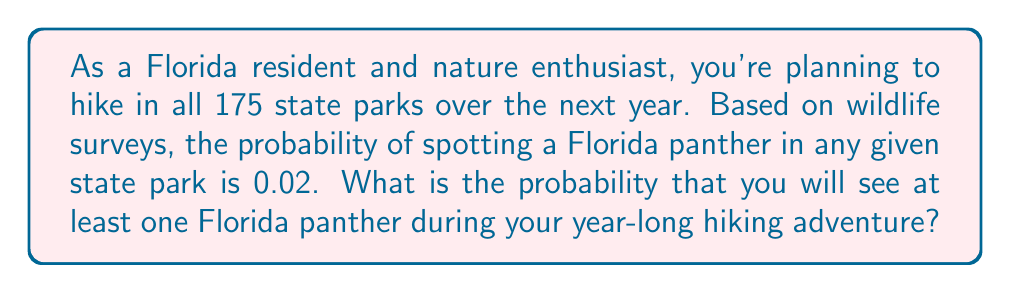Give your solution to this math problem. To solve this problem, we'll use the complement rule of probability. Instead of calculating the probability of seeing at least one panther, we'll calculate the probability of not seeing any panthers and then subtract that from 1.

Let's break it down step by step:

1) The probability of not seeing a panther in one park is:
   $1 - 0.02 = 0.98$

2) You're visiting all 175 state parks. To not see a panther at all, you would need to not see one in every single park. The probability of this happening is:
   $(0.98)^{175}$

3) Therefore, the probability of seeing at least one panther is:
   $1 - (0.98)^{175}$

4) Let's calculate this:
   $$\begin{align*}
   P(\text{at least one panther}) &= 1 - (0.98)^{175} \\
   &= 1 - 0.0282 \\
   &= 0.9718
   \end{align*}$$

5) Converting to a percentage:
   $0.9718 \times 100\% = 97.18\%$
Answer: The probability of seeing at least one Florida panther during your year-long hiking adventure in all 175 Florida state parks is approximately 97.18%. 